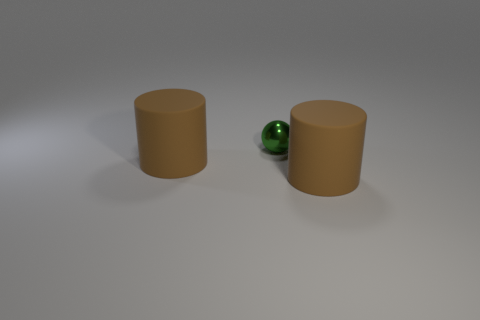Is there any other thing that is the same material as the tiny thing?
Give a very brief answer. No. The large matte thing that is in front of the big thing that is behind the brown object on the right side of the ball is what color?
Your response must be concise. Brown. What color is the shiny sphere?
Ensure brevity in your answer.  Green. The cylinder in front of the cylinder left of the tiny green metal sphere is what color?
Make the answer very short. Brown. How many things are either matte cylinders left of the green thing or brown cylinders to the left of the metallic ball?
Provide a succinct answer. 1. How many big brown cylinders are right of the big matte object to the right of the tiny object?
Ensure brevity in your answer.  0. Is there another ball made of the same material as the green sphere?
Ensure brevity in your answer.  No. How many rubber objects are either green spheres or tiny cyan objects?
Offer a terse response. 0. What is the shape of the thing behind the large rubber cylinder that is left of the green sphere?
Your answer should be very brief. Sphere. Are there fewer brown matte cylinders that are to the left of the metal ball than big gray cylinders?
Offer a terse response. No. 